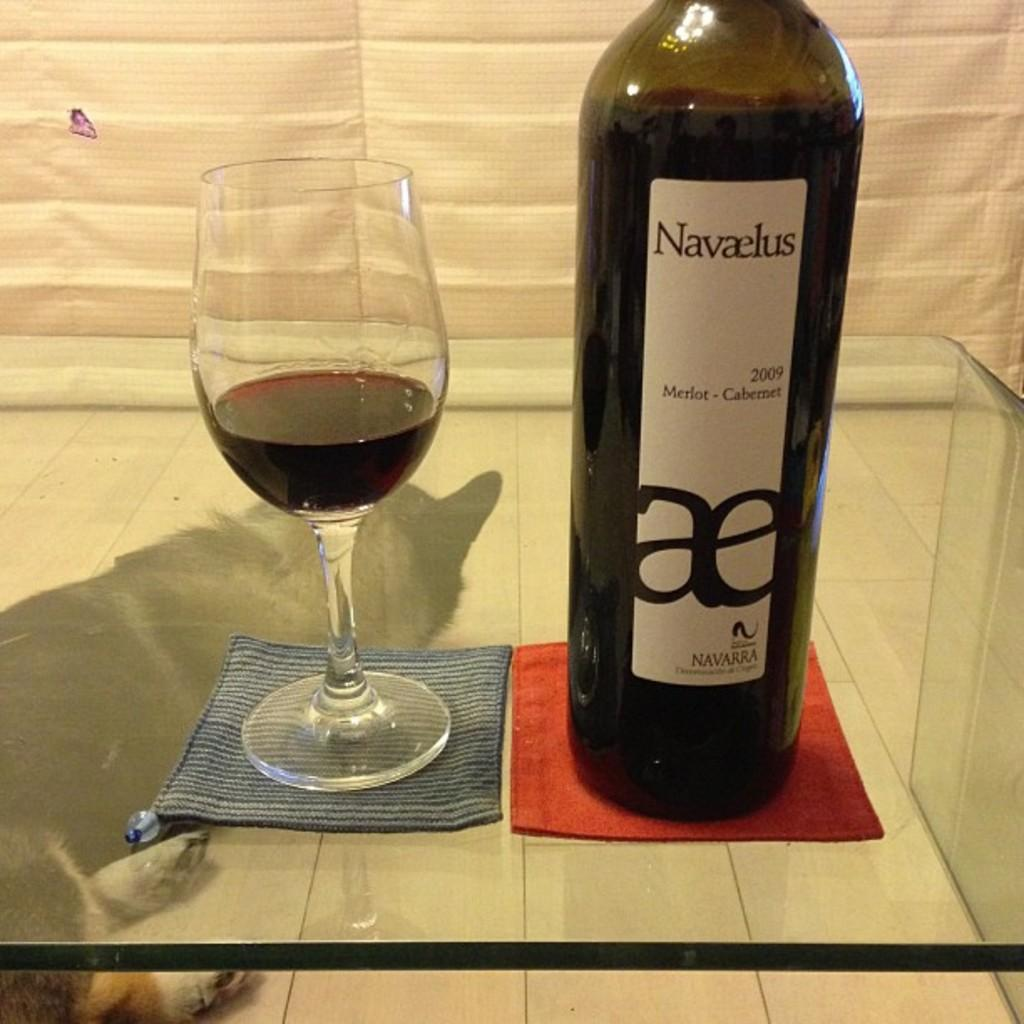What is in the wine glass that is visible in the image? There is a wine glass with wine in the image. What else can be seen related to wine in the image? There is a wine bottle with a label in the image. Where are the wine glass and wine bottle located in the image? The wine glass and wine bottle are on a glass table in the image. What can be seen in the background of the image? There is a cloth and an animal leg in the background of the image. How many cobwebs can be seen in the image? There are no cobwebs present in the image. What type of secretary is sitting next to the glass table in the image? There is no secretary present in the image. 